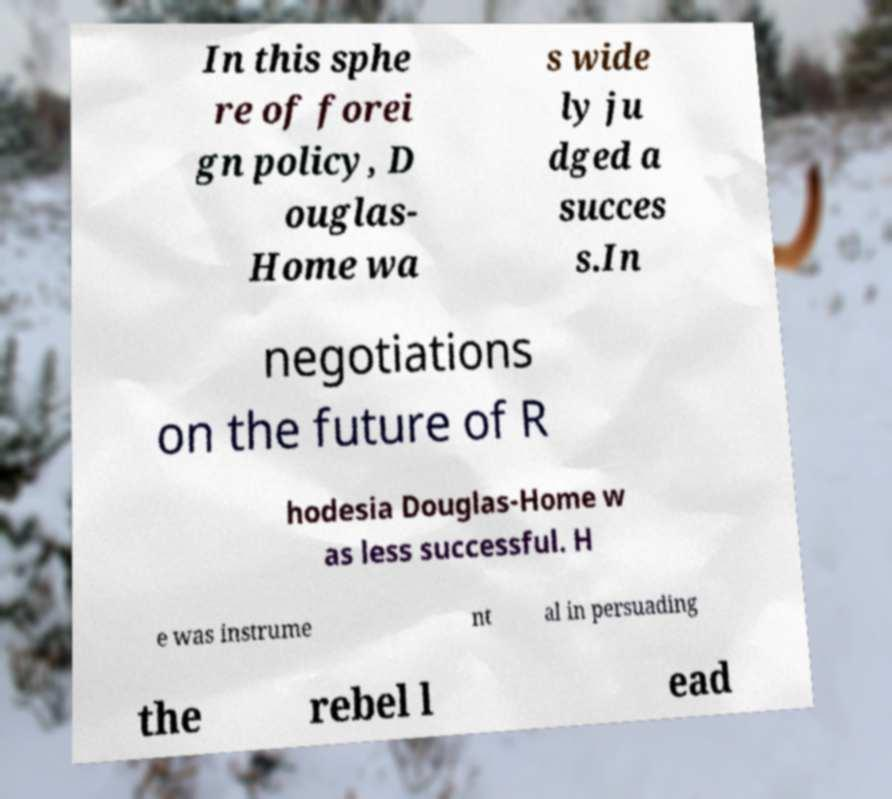What messages or text are displayed in this image? I need them in a readable, typed format. In this sphe re of forei gn policy, D ouglas- Home wa s wide ly ju dged a succes s.In negotiations on the future of R hodesia Douglas-Home w as less successful. H e was instrume nt al in persuading the rebel l ead 